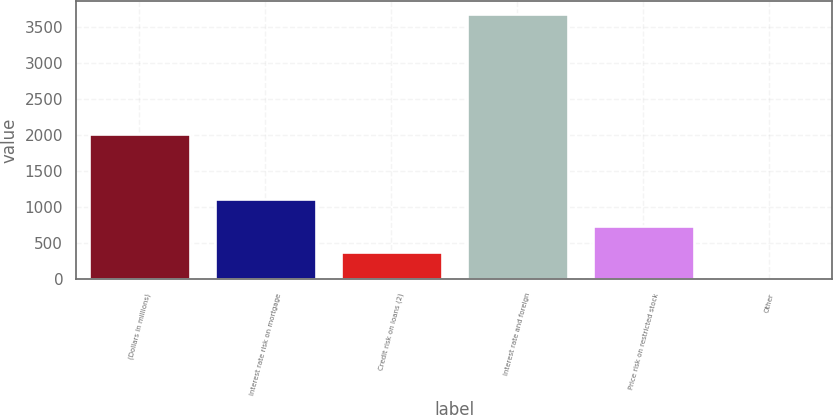<chart> <loc_0><loc_0><loc_500><loc_500><bar_chart><fcel>(Dollars in millions)<fcel>Interest rate risk on mortgage<fcel>Credit risk on loans (2)<fcel>Interest rate and foreign<fcel>Price risk on restricted stock<fcel>Other<nl><fcel>2014<fcel>1111.2<fcel>376.4<fcel>3683<fcel>743.8<fcel>9<nl></chart> 